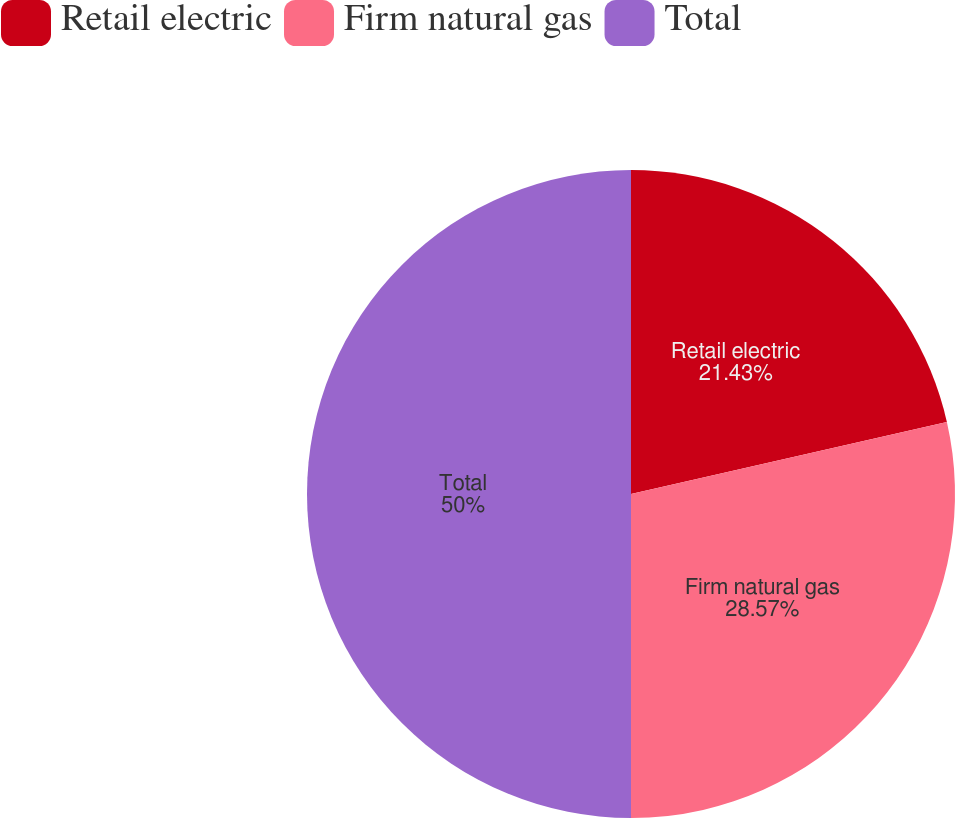Convert chart. <chart><loc_0><loc_0><loc_500><loc_500><pie_chart><fcel>Retail electric<fcel>Firm natural gas<fcel>Total<nl><fcel>21.43%<fcel>28.57%<fcel>50.0%<nl></chart> 